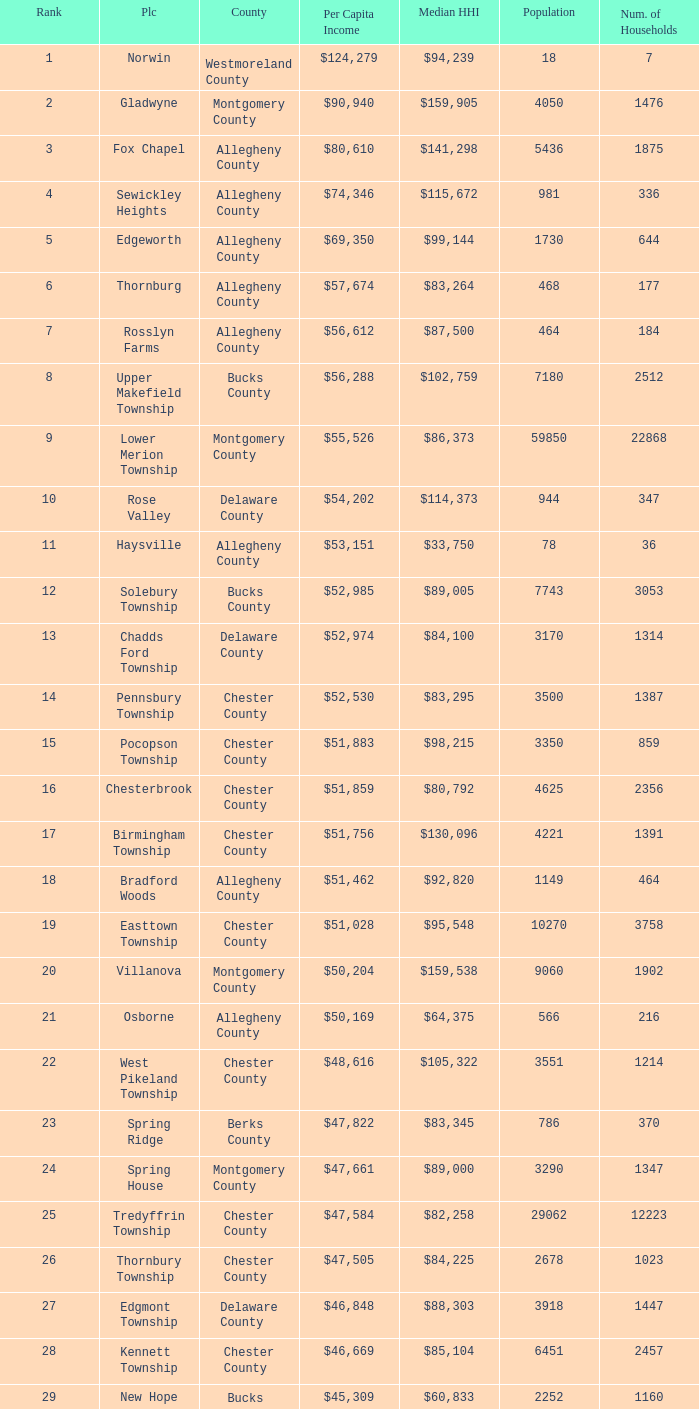Which county has a median household income of  $98,090? Bucks County. 